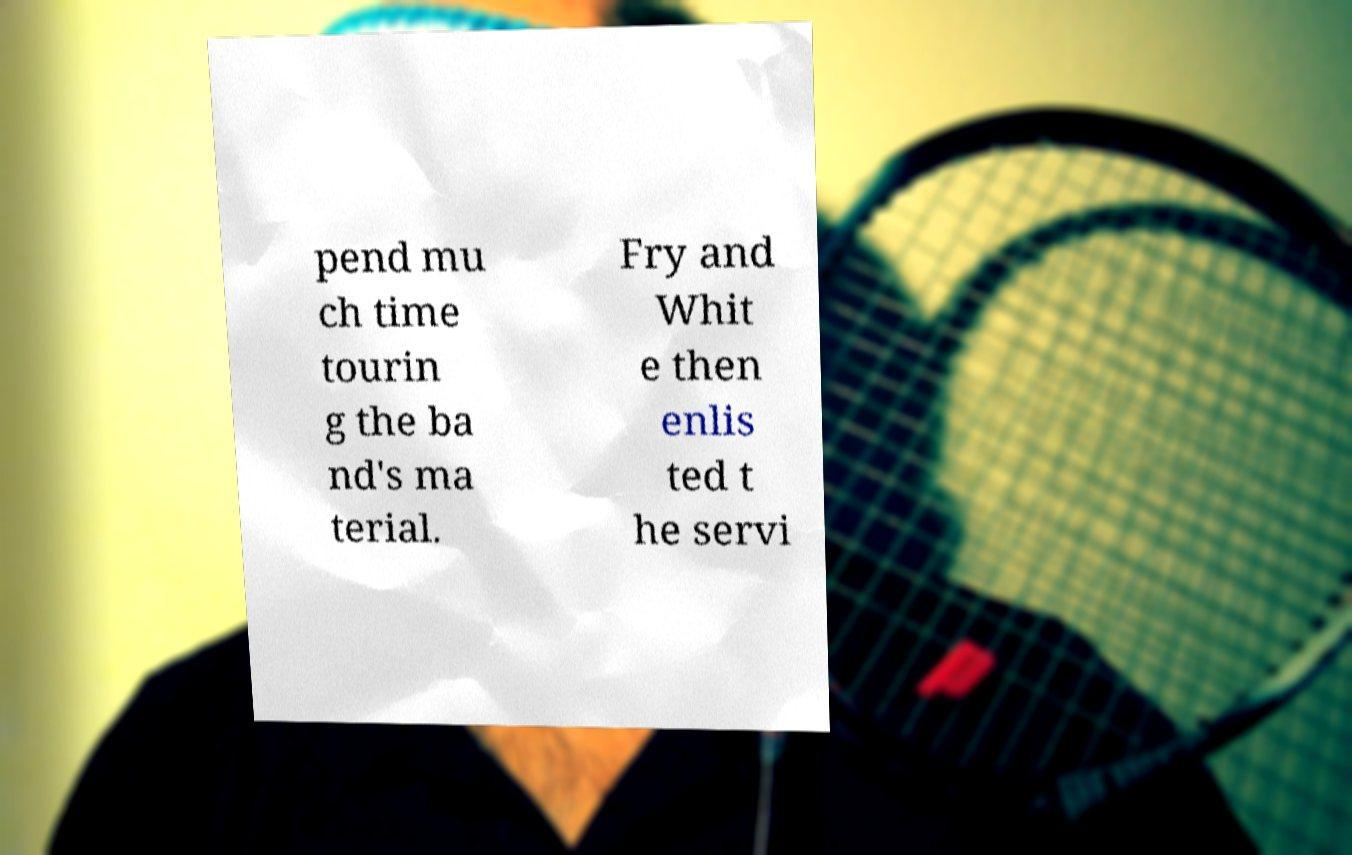There's text embedded in this image that I need extracted. Can you transcribe it verbatim? pend mu ch time tourin g the ba nd's ma terial. Fry and Whit e then enlis ted t he servi 